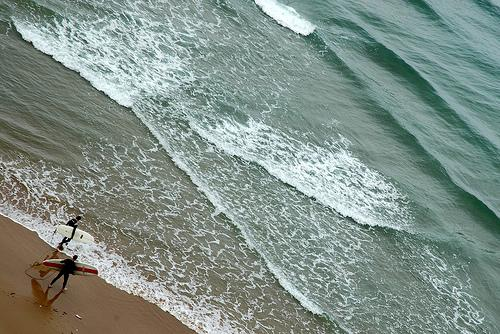Question: what is the person carrying?
Choices:
A. Sun tan lotion.
B. Goggles.
C. A surfboard.
D. Towel.
Answer with the letter. Answer: C Question: how many people are in this picture?
Choices:
A. 4.
B. 5.
C. 6.
D. 2.
Answer with the letter. Answer: D Question: where are they surfing?
Choices:
A. The ocean.
B. Lake.
C. River.
D. Pond.
Answer with the letter. Answer: A Question: what color is the land?
Choices:
A. Grey.
B. Brown.
C. Black.
D. Red.
Answer with the letter. Answer: B Question: where are these people?
Choices:
A. On the beach.
B. Hotel.
C. Park.
D. Zoo.
Answer with the letter. Answer: A 